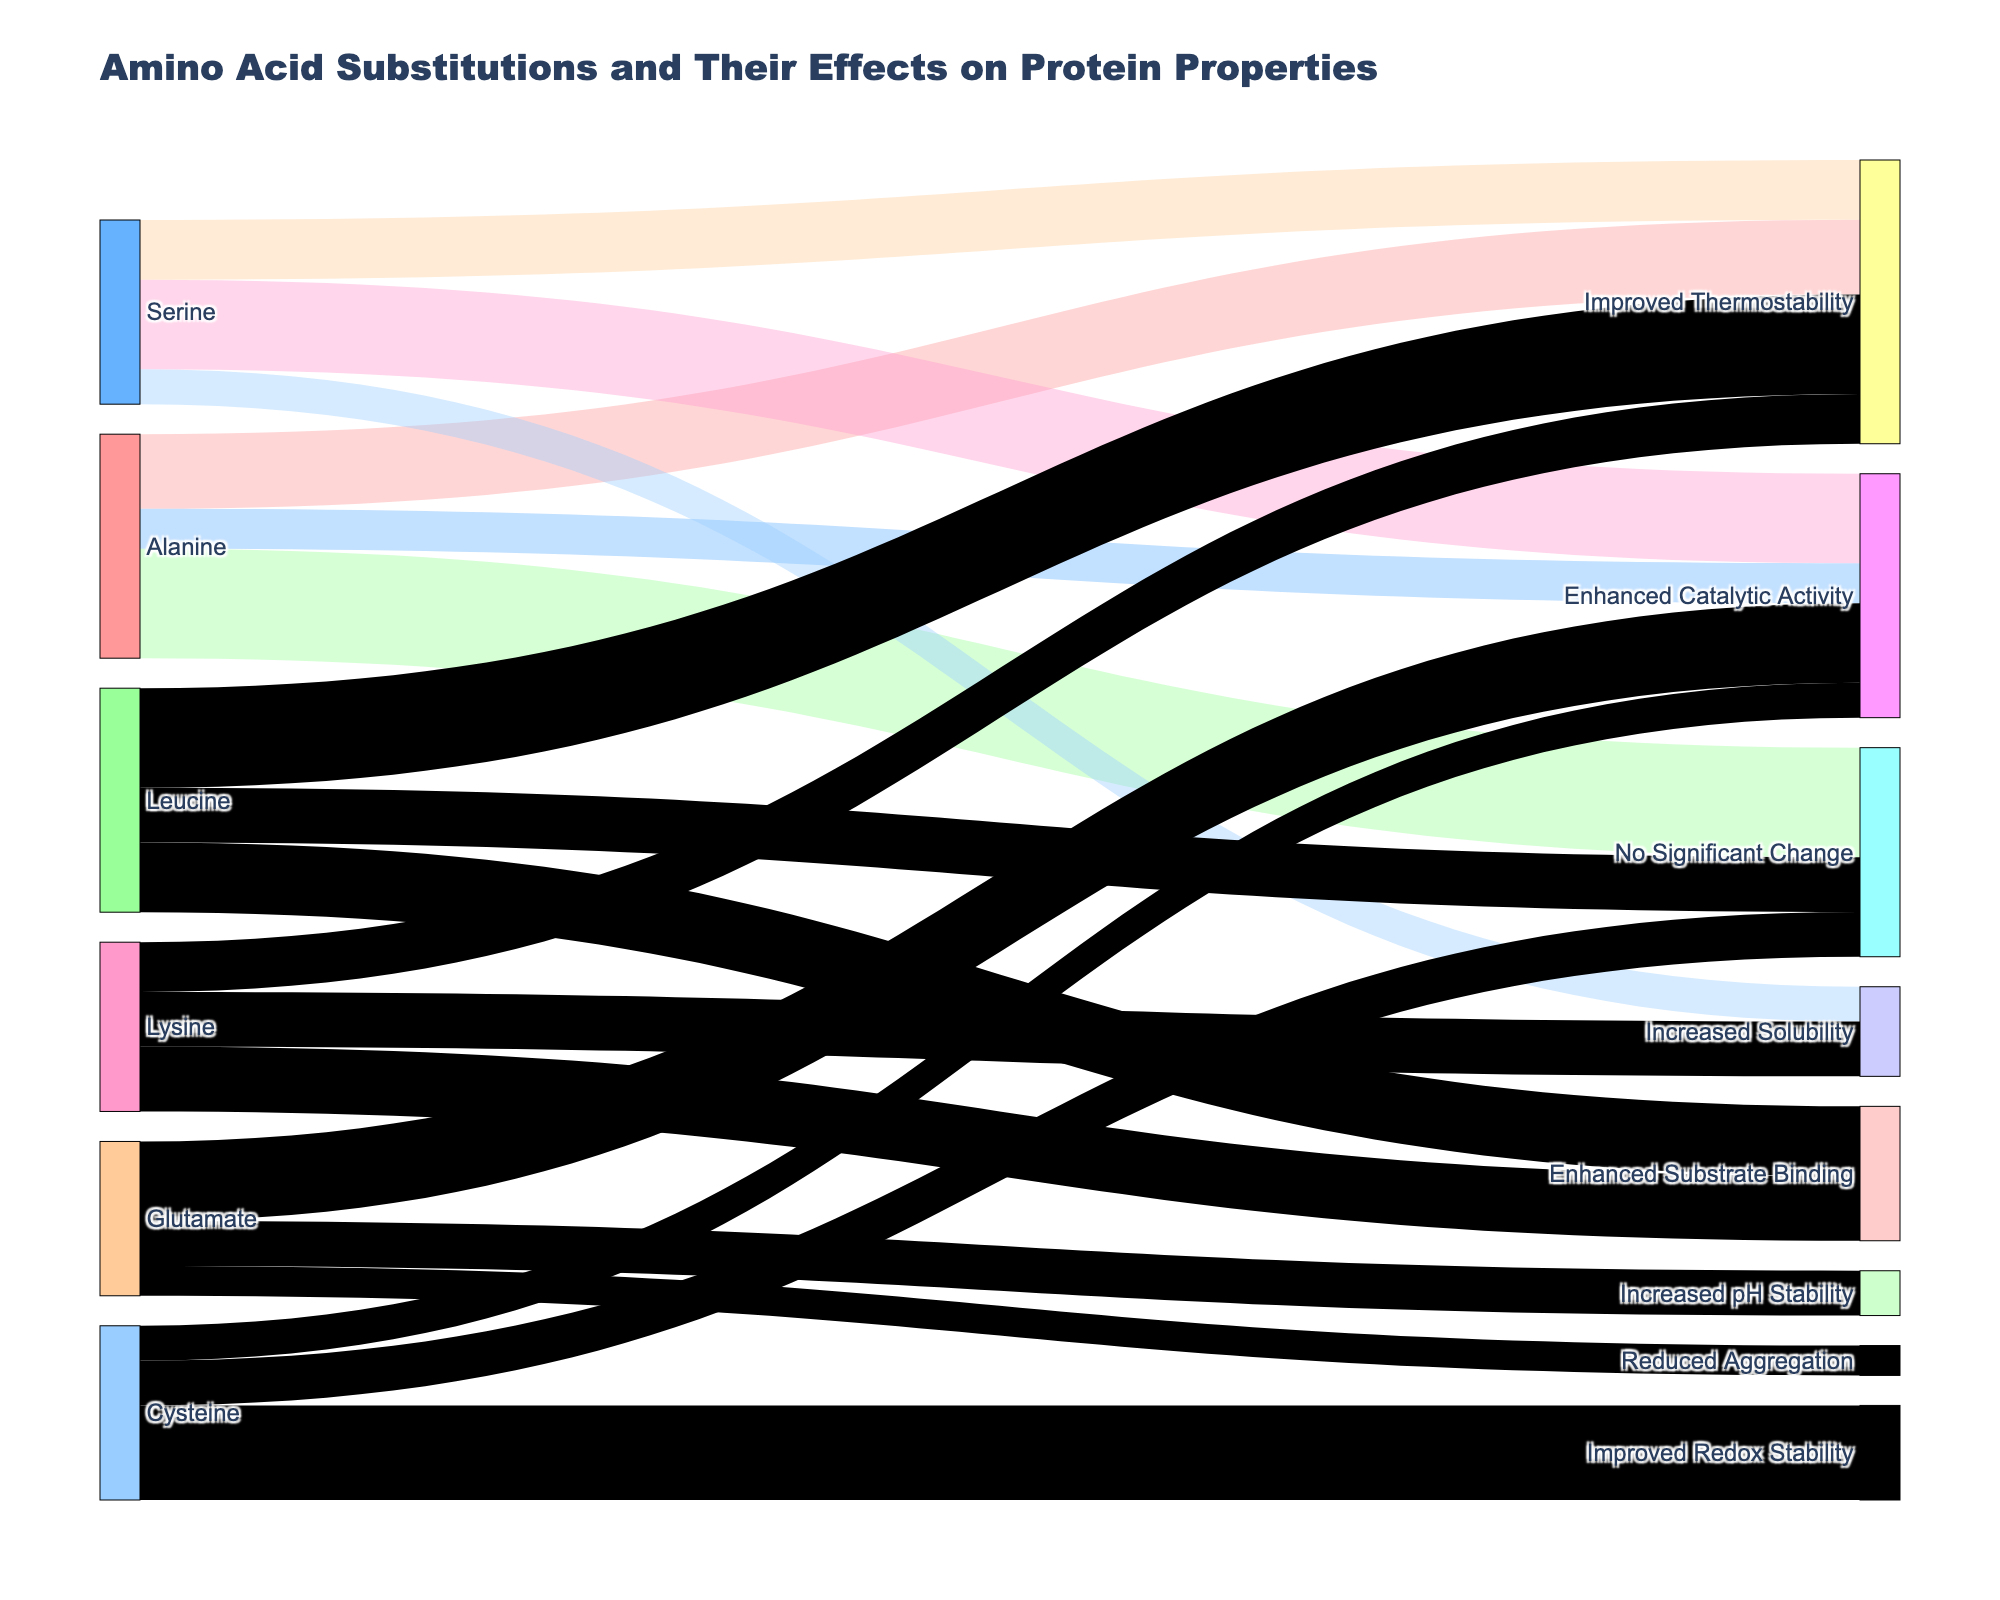What is the total number of amino acid substitutions that resulted in improved thermostability? Sum the values associated with "Improved Thermostability" from Alanine (15), Serine (12), Leucine (20), and Lysine (10). 15 + 12 + 20 + 10 = 57
Answer: 57 Which amino acid has the highest number of substitutions leading to enhanced catalytic activity? Compare the values of Alanine (8), Serine (18), Glutamate (16), and Cysteine (7). The highest value is for Serine with 18.
Answer: Serine How many amino acid substitutions resulted in no significant change? Sum the values associated with "No Significant Change" from Alanine (22), Leucine (11), and Cysteine (9). 22 + 11 + 9 = 42
Answer: 42 Which effect has the fewest associated amino acid substitutions? Compare the total values for each effect. "Improved Redox Stability" has only one entry with a value of 19.
Answer: Improved Redox Stability What is the total number of substitutions for Alanine? Sum the values associated with Alanine: Improved Thermostability (15), Enhanced Catalytic Activity (8), and No Significant Change (22). 15 + 8 + 22 = 45
Answer: 45 Which amino acid had the most diverse range of effects based on the number of different targets? Count the different effects for each amino acid. Alanine, Leucine, and Lysine each affect three different properties, while Serine affects four different properties.
Answer: Serine Among the effects related to enhanced substrate binding, which amino acid contributed the most? Compare the values for Leucine (14) and Lysine (13). Leucine has a higher value of 14.
Answer: Leucine How many amino acid substitutions resulted in increased solubility? Sum the values associated with "Increased Solubility" from Serine (7) and Lysine (11). 7 + 11 = 18
Answer: 18 Which effect had the highest total number of amino acid substitutions? Compare the sum of values for each effect: "No Significant Change" (42), "Improved Thermostability" (57), etc. "Improved Thermostability" sums up to 57 which is the highest.
Answer: Improved Thermostability What is the average number of substitutions for those leading to enhanced catalytic activity? Calculate the average from the values 8, 18, 16, and 7. (8 + 18 + 16 + 7) / 4 = 49 / 4 = 12.25
Answer: 12.25 